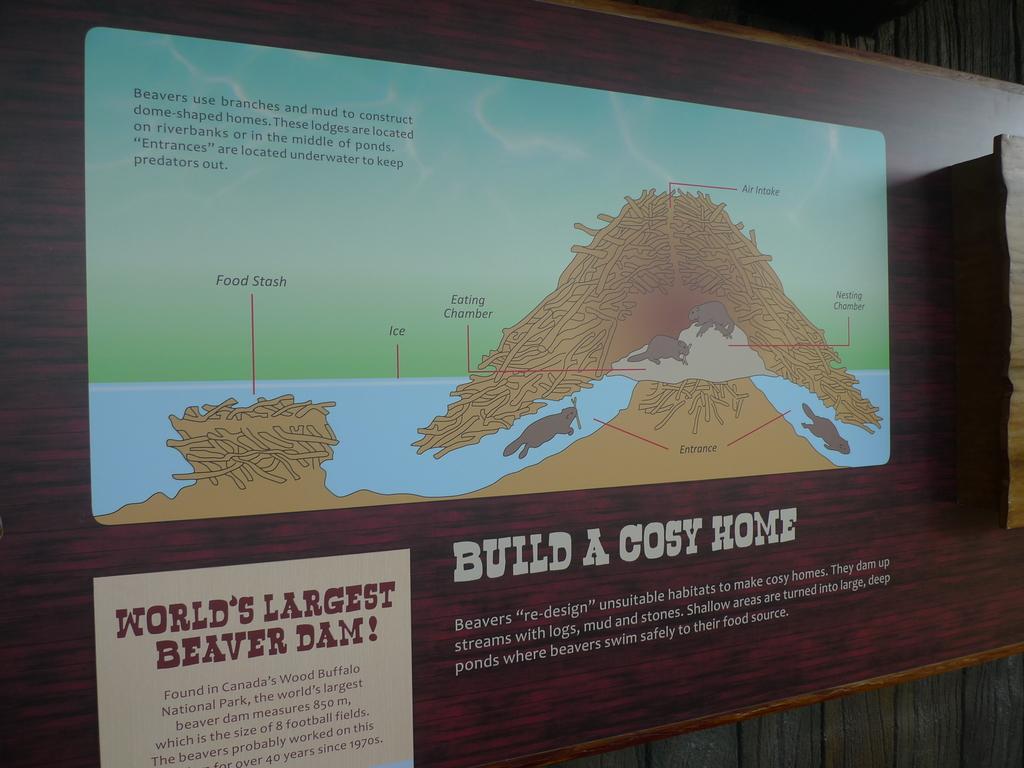What do beavers use to construct their dome-shaped homes?
Give a very brief answer. Branches and mud. 